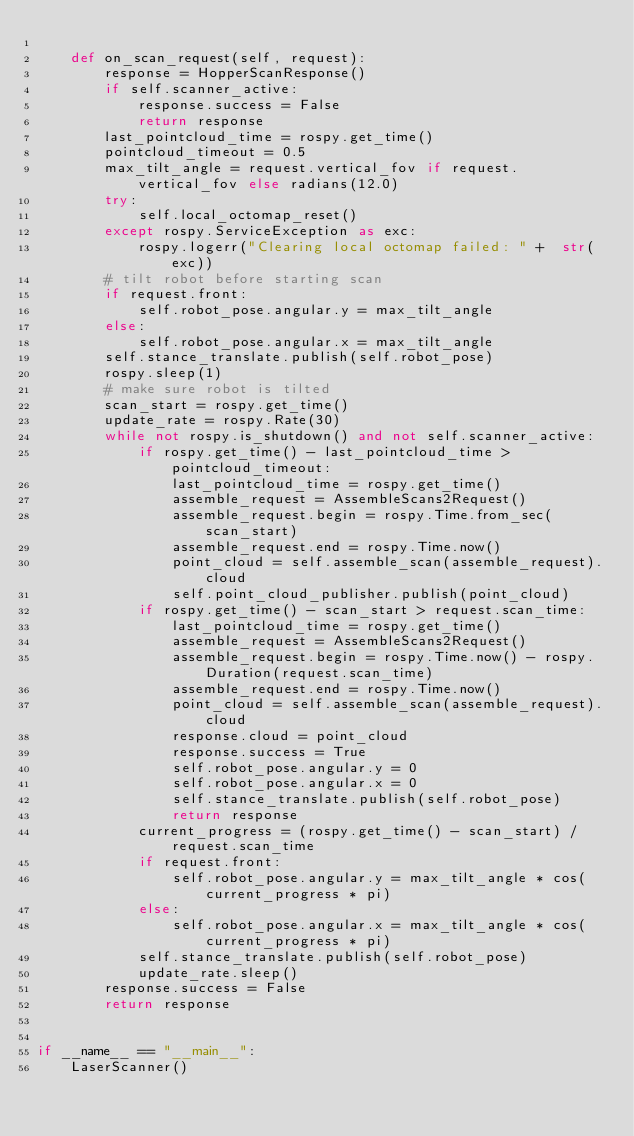<code> <loc_0><loc_0><loc_500><loc_500><_Python_>
    def on_scan_request(self, request):
        response = HopperScanResponse()
        if self.scanner_active:
            response.success = False
            return response
        last_pointcloud_time = rospy.get_time()
        pointcloud_timeout = 0.5
        max_tilt_angle = request.vertical_fov if request.vertical_fov else radians(12.0)
        try:
            self.local_octomap_reset()
        except rospy.ServiceException as exc:
            rospy.logerr("Clearing local octomap failed: " +  str(exc))
        # tilt robot before starting scan
        if request.front:
            self.robot_pose.angular.y = max_tilt_angle
        else:
            self.robot_pose.angular.x = max_tilt_angle
        self.stance_translate.publish(self.robot_pose)
        rospy.sleep(1)
        # make sure robot is tilted
        scan_start = rospy.get_time()
        update_rate = rospy.Rate(30)
        while not rospy.is_shutdown() and not self.scanner_active:
            if rospy.get_time() - last_pointcloud_time > pointcloud_timeout:
                last_pointcloud_time = rospy.get_time()
                assemble_request = AssembleScans2Request()
                assemble_request.begin = rospy.Time.from_sec(scan_start)
                assemble_request.end = rospy.Time.now()
                point_cloud = self.assemble_scan(assemble_request).cloud
                self.point_cloud_publisher.publish(point_cloud)
            if rospy.get_time() - scan_start > request.scan_time:
                last_pointcloud_time = rospy.get_time()
                assemble_request = AssembleScans2Request()
                assemble_request.begin = rospy.Time.now() - rospy.Duration(request.scan_time)
                assemble_request.end = rospy.Time.now()
                point_cloud = self.assemble_scan(assemble_request).cloud
                response.cloud = point_cloud
                response.success = True
                self.robot_pose.angular.y = 0
                self.robot_pose.angular.x = 0
                self.stance_translate.publish(self.robot_pose)
                return response
            current_progress = (rospy.get_time() - scan_start) / request.scan_time
            if request.front:
                self.robot_pose.angular.y = max_tilt_angle * cos(current_progress * pi)
            else:
                self.robot_pose.angular.x = max_tilt_angle * cos(current_progress * pi)
            self.stance_translate.publish(self.robot_pose)
            update_rate.sleep()
        response.success = False
        return response


if __name__ == "__main__":
    LaserScanner()
</code> 